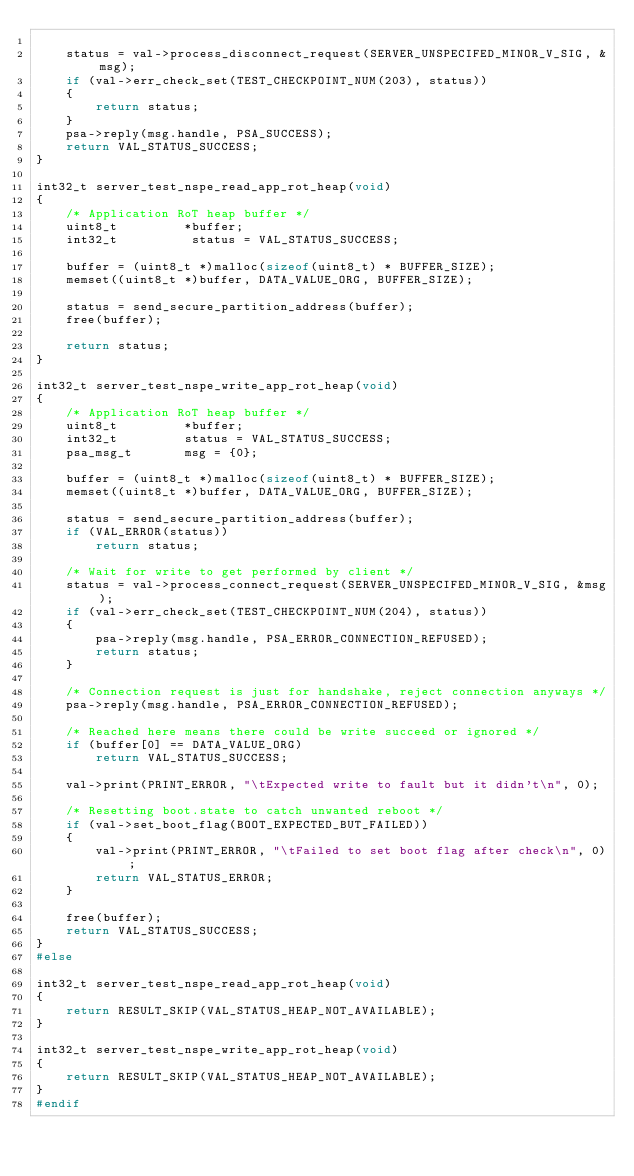<code> <loc_0><loc_0><loc_500><loc_500><_C_>
    status = val->process_disconnect_request(SERVER_UNSPECIFED_MINOR_V_SIG, &msg);
    if (val->err_check_set(TEST_CHECKPOINT_NUM(203), status))
    {
        return status;
    }
    psa->reply(msg.handle, PSA_SUCCESS);
    return VAL_STATUS_SUCCESS;
}

int32_t server_test_nspe_read_app_rot_heap(void)
{
    /* Application RoT heap buffer */
    uint8_t         *buffer;
    int32_t          status = VAL_STATUS_SUCCESS;

    buffer = (uint8_t *)malloc(sizeof(uint8_t) * BUFFER_SIZE);
    memset((uint8_t *)buffer, DATA_VALUE_ORG, BUFFER_SIZE);

    status = send_secure_partition_address(buffer);
    free(buffer);

    return status;
}

int32_t server_test_nspe_write_app_rot_heap(void)
{
    /* Application RoT heap buffer */
    uint8_t         *buffer;
    int32_t         status = VAL_STATUS_SUCCESS;
    psa_msg_t       msg = {0};

    buffer = (uint8_t *)malloc(sizeof(uint8_t) * BUFFER_SIZE);
    memset((uint8_t *)buffer, DATA_VALUE_ORG, BUFFER_SIZE);

    status = send_secure_partition_address(buffer);
    if (VAL_ERROR(status))
        return status;

    /* Wait for write to get performed by client */
    status = val->process_connect_request(SERVER_UNSPECIFED_MINOR_V_SIG, &msg);
    if (val->err_check_set(TEST_CHECKPOINT_NUM(204), status))
    {
        psa->reply(msg.handle, PSA_ERROR_CONNECTION_REFUSED);
        return status;
    }

    /* Connection request is just for handshake, reject connection anyways */
    psa->reply(msg.handle, PSA_ERROR_CONNECTION_REFUSED);

    /* Reached here means there could be write succeed or ignored */
    if (buffer[0] == DATA_VALUE_ORG)
        return VAL_STATUS_SUCCESS;

    val->print(PRINT_ERROR, "\tExpected write to fault but it didn't\n", 0);

    /* Resetting boot.state to catch unwanted reboot */
    if (val->set_boot_flag(BOOT_EXPECTED_BUT_FAILED))
    {
        val->print(PRINT_ERROR, "\tFailed to set boot flag after check\n", 0);
        return VAL_STATUS_ERROR;
    }

    free(buffer);
    return VAL_STATUS_SUCCESS;
}
#else

int32_t server_test_nspe_read_app_rot_heap(void)
{
    return RESULT_SKIP(VAL_STATUS_HEAP_NOT_AVAILABLE);
}

int32_t server_test_nspe_write_app_rot_heap(void)
{
    return RESULT_SKIP(VAL_STATUS_HEAP_NOT_AVAILABLE);
}
#endif
</code> 